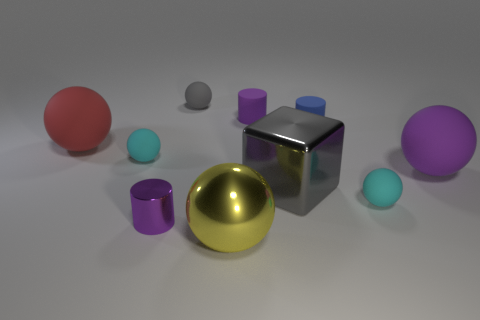Subtract 2 balls. How many balls are left? 4 Subtract all purple spheres. How many spheres are left? 5 Subtract all cyan rubber spheres. How many spheres are left? 4 Subtract all yellow spheres. Subtract all blue cylinders. How many spheres are left? 5 Subtract all spheres. How many objects are left? 4 Subtract 0 yellow cylinders. How many objects are left? 10 Subtract all small cylinders. Subtract all yellow things. How many objects are left? 6 Add 5 big gray cubes. How many big gray cubes are left? 6 Add 5 large purple balls. How many large purple balls exist? 6 